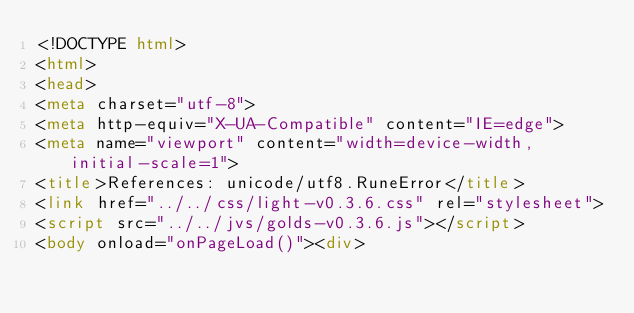Convert code to text. <code><loc_0><loc_0><loc_500><loc_500><_HTML_><!DOCTYPE html>
<html>
<head>
<meta charset="utf-8">
<meta http-equiv="X-UA-Compatible" content="IE=edge">
<meta name="viewport" content="width=device-width, initial-scale=1">
<title>References: unicode/utf8.RuneError</title>
<link href="../../css/light-v0.3.6.css" rel="stylesheet">
<script src="../../jvs/golds-v0.3.6.js"></script>
<body onload="onPageLoad()"><div>
</code> 